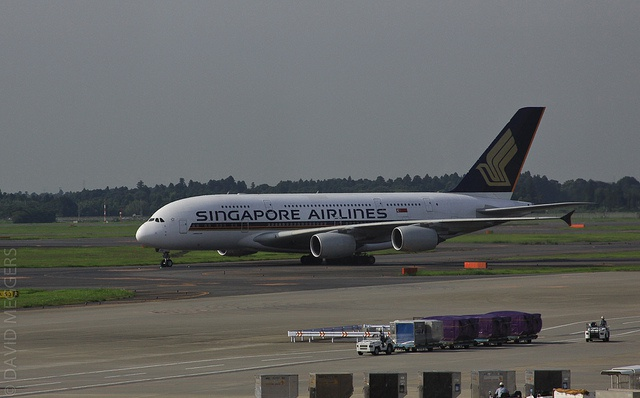Describe the objects in this image and their specific colors. I can see airplane in gray, black, and darkgray tones, truck in gray and black tones, truck in gray and black tones, truck in gray and black tones, and truck in gray and black tones in this image. 